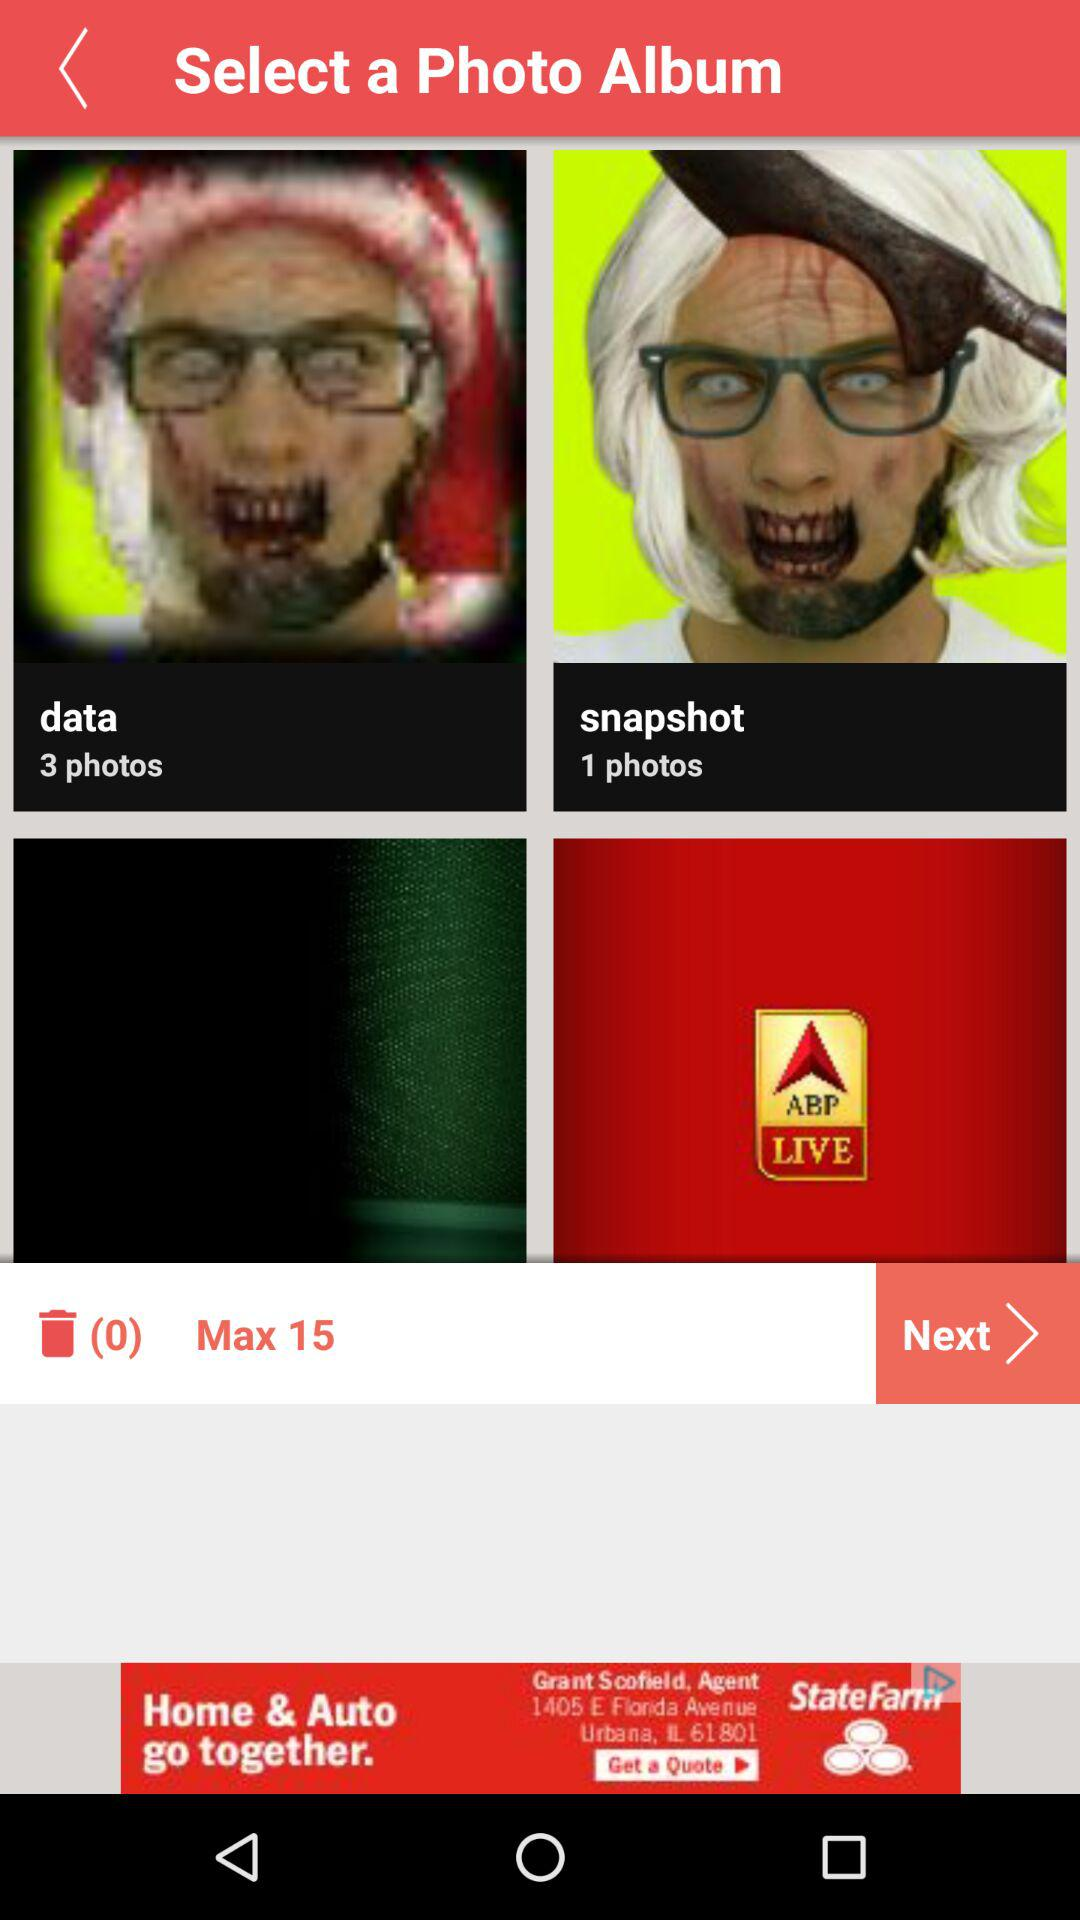What is the maximum number of photo albums that can be selected? The maximum number of photo albums that can be selected is 15. 